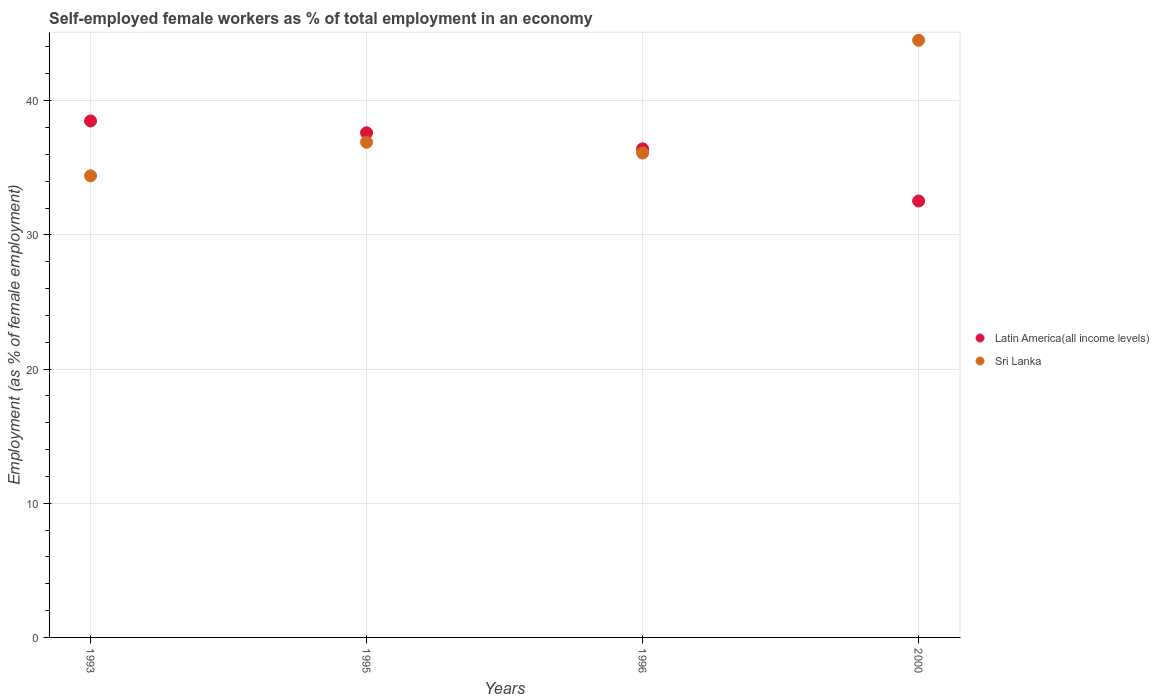How many different coloured dotlines are there?
Provide a short and direct response. 2. What is the percentage of self-employed female workers in Latin America(all income levels) in 1993?
Your response must be concise. 38.49. Across all years, what is the maximum percentage of self-employed female workers in Sri Lanka?
Ensure brevity in your answer.  44.5. Across all years, what is the minimum percentage of self-employed female workers in Sri Lanka?
Give a very brief answer. 34.4. In which year was the percentage of self-employed female workers in Latin America(all income levels) minimum?
Keep it short and to the point. 2000. What is the total percentage of self-employed female workers in Sri Lanka in the graph?
Ensure brevity in your answer.  151.9. What is the difference between the percentage of self-employed female workers in Sri Lanka in 1995 and that in 1996?
Provide a short and direct response. 0.8. What is the difference between the percentage of self-employed female workers in Sri Lanka in 1993 and the percentage of self-employed female workers in Latin America(all income levels) in 2000?
Provide a succinct answer. 1.88. What is the average percentage of self-employed female workers in Latin America(all income levels) per year?
Keep it short and to the point. 36.26. In the year 1995, what is the difference between the percentage of self-employed female workers in Sri Lanka and percentage of self-employed female workers in Latin America(all income levels)?
Your response must be concise. -0.71. What is the ratio of the percentage of self-employed female workers in Sri Lanka in 1993 to that in 2000?
Your response must be concise. 0.77. Is the percentage of self-employed female workers in Latin America(all income levels) in 1995 less than that in 1996?
Offer a very short reply. No. Is the difference between the percentage of self-employed female workers in Sri Lanka in 1993 and 1995 greater than the difference between the percentage of self-employed female workers in Latin America(all income levels) in 1993 and 1995?
Your answer should be compact. No. What is the difference between the highest and the second highest percentage of self-employed female workers in Latin America(all income levels)?
Your answer should be compact. 0.88. What is the difference between the highest and the lowest percentage of self-employed female workers in Latin America(all income levels)?
Your answer should be very brief. 5.97. Is the sum of the percentage of self-employed female workers in Latin America(all income levels) in 1995 and 1996 greater than the maximum percentage of self-employed female workers in Sri Lanka across all years?
Keep it short and to the point. Yes. Does the percentage of self-employed female workers in Sri Lanka monotonically increase over the years?
Your answer should be very brief. No. Is the percentage of self-employed female workers in Sri Lanka strictly greater than the percentage of self-employed female workers in Latin America(all income levels) over the years?
Offer a terse response. No. How many dotlines are there?
Ensure brevity in your answer.  2. Are the values on the major ticks of Y-axis written in scientific E-notation?
Your answer should be compact. No. Does the graph contain any zero values?
Your response must be concise. No. Does the graph contain grids?
Provide a short and direct response. Yes. How many legend labels are there?
Make the answer very short. 2. What is the title of the graph?
Provide a short and direct response. Self-employed female workers as % of total employment in an economy. Does "Micronesia" appear as one of the legend labels in the graph?
Your answer should be very brief. No. What is the label or title of the Y-axis?
Your answer should be compact. Employment (as % of female employment). What is the Employment (as % of female employment) in Latin America(all income levels) in 1993?
Your answer should be very brief. 38.49. What is the Employment (as % of female employment) in Sri Lanka in 1993?
Keep it short and to the point. 34.4. What is the Employment (as % of female employment) of Latin America(all income levels) in 1995?
Provide a succinct answer. 37.61. What is the Employment (as % of female employment) of Sri Lanka in 1995?
Offer a terse response. 36.9. What is the Employment (as % of female employment) in Latin America(all income levels) in 1996?
Provide a short and direct response. 36.41. What is the Employment (as % of female employment) in Sri Lanka in 1996?
Your response must be concise. 36.1. What is the Employment (as % of female employment) in Latin America(all income levels) in 2000?
Provide a short and direct response. 32.52. What is the Employment (as % of female employment) of Sri Lanka in 2000?
Your answer should be compact. 44.5. Across all years, what is the maximum Employment (as % of female employment) in Latin America(all income levels)?
Keep it short and to the point. 38.49. Across all years, what is the maximum Employment (as % of female employment) of Sri Lanka?
Provide a succinct answer. 44.5. Across all years, what is the minimum Employment (as % of female employment) of Latin America(all income levels)?
Keep it short and to the point. 32.52. Across all years, what is the minimum Employment (as % of female employment) of Sri Lanka?
Your answer should be very brief. 34.4. What is the total Employment (as % of female employment) of Latin America(all income levels) in the graph?
Your response must be concise. 145.03. What is the total Employment (as % of female employment) of Sri Lanka in the graph?
Provide a short and direct response. 151.9. What is the difference between the Employment (as % of female employment) of Latin America(all income levels) in 1993 and that in 1995?
Your answer should be compact. 0.88. What is the difference between the Employment (as % of female employment) of Sri Lanka in 1993 and that in 1995?
Your answer should be compact. -2.5. What is the difference between the Employment (as % of female employment) of Latin America(all income levels) in 1993 and that in 1996?
Ensure brevity in your answer.  2.08. What is the difference between the Employment (as % of female employment) of Sri Lanka in 1993 and that in 1996?
Keep it short and to the point. -1.7. What is the difference between the Employment (as % of female employment) in Latin America(all income levels) in 1993 and that in 2000?
Your answer should be compact. 5.97. What is the difference between the Employment (as % of female employment) in Sri Lanka in 1993 and that in 2000?
Your answer should be compact. -10.1. What is the difference between the Employment (as % of female employment) in Latin America(all income levels) in 1995 and that in 1996?
Provide a short and direct response. 1.2. What is the difference between the Employment (as % of female employment) in Sri Lanka in 1995 and that in 1996?
Provide a short and direct response. 0.8. What is the difference between the Employment (as % of female employment) in Latin America(all income levels) in 1995 and that in 2000?
Make the answer very short. 5.08. What is the difference between the Employment (as % of female employment) of Sri Lanka in 1995 and that in 2000?
Ensure brevity in your answer.  -7.6. What is the difference between the Employment (as % of female employment) in Latin America(all income levels) in 1996 and that in 2000?
Provide a short and direct response. 3.89. What is the difference between the Employment (as % of female employment) of Sri Lanka in 1996 and that in 2000?
Provide a short and direct response. -8.4. What is the difference between the Employment (as % of female employment) of Latin America(all income levels) in 1993 and the Employment (as % of female employment) of Sri Lanka in 1995?
Offer a very short reply. 1.59. What is the difference between the Employment (as % of female employment) of Latin America(all income levels) in 1993 and the Employment (as % of female employment) of Sri Lanka in 1996?
Offer a terse response. 2.39. What is the difference between the Employment (as % of female employment) in Latin America(all income levels) in 1993 and the Employment (as % of female employment) in Sri Lanka in 2000?
Make the answer very short. -6.01. What is the difference between the Employment (as % of female employment) in Latin America(all income levels) in 1995 and the Employment (as % of female employment) in Sri Lanka in 1996?
Keep it short and to the point. 1.51. What is the difference between the Employment (as % of female employment) in Latin America(all income levels) in 1995 and the Employment (as % of female employment) in Sri Lanka in 2000?
Make the answer very short. -6.89. What is the difference between the Employment (as % of female employment) in Latin America(all income levels) in 1996 and the Employment (as % of female employment) in Sri Lanka in 2000?
Your answer should be compact. -8.09. What is the average Employment (as % of female employment) of Latin America(all income levels) per year?
Keep it short and to the point. 36.26. What is the average Employment (as % of female employment) of Sri Lanka per year?
Ensure brevity in your answer.  37.98. In the year 1993, what is the difference between the Employment (as % of female employment) in Latin America(all income levels) and Employment (as % of female employment) in Sri Lanka?
Keep it short and to the point. 4.09. In the year 1995, what is the difference between the Employment (as % of female employment) in Latin America(all income levels) and Employment (as % of female employment) in Sri Lanka?
Offer a terse response. 0.71. In the year 1996, what is the difference between the Employment (as % of female employment) in Latin America(all income levels) and Employment (as % of female employment) in Sri Lanka?
Your answer should be compact. 0.31. In the year 2000, what is the difference between the Employment (as % of female employment) in Latin America(all income levels) and Employment (as % of female employment) in Sri Lanka?
Your answer should be compact. -11.98. What is the ratio of the Employment (as % of female employment) of Latin America(all income levels) in 1993 to that in 1995?
Give a very brief answer. 1.02. What is the ratio of the Employment (as % of female employment) in Sri Lanka in 1993 to that in 1995?
Give a very brief answer. 0.93. What is the ratio of the Employment (as % of female employment) in Latin America(all income levels) in 1993 to that in 1996?
Your answer should be compact. 1.06. What is the ratio of the Employment (as % of female employment) of Sri Lanka in 1993 to that in 1996?
Provide a short and direct response. 0.95. What is the ratio of the Employment (as % of female employment) in Latin America(all income levels) in 1993 to that in 2000?
Ensure brevity in your answer.  1.18. What is the ratio of the Employment (as % of female employment) of Sri Lanka in 1993 to that in 2000?
Your answer should be very brief. 0.77. What is the ratio of the Employment (as % of female employment) in Latin America(all income levels) in 1995 to that in 1996?
Keep it short and to the point. 1.03. What is the ratio of the Employment (as % of female employment) in Sri Lanka in 1995 to that in 1996?
Your answer should be very brief. 1.02. What is the ratio of the Employment (as % of female employment) of Latin America(all income levels) in 1995 to that in 2000?
Provide a short and direct response. 1.16. What is the ratio of the Employment (as % of female employment) of Sri Lanka in 1995 to that in 2000?
Your answer should be compact. 0.83. What is the ratio of the Employment (as % of female employment) of Latin America(all income levels) in 1996 to that in 2000?
Keep it short and to the point. 1.12. What is the ratio of the Employment (as % of female employment) in Sri Lanka in 1996 to that in 2000?
Your response must be concise. 0.81. What is the difference between the highest and the second highest Employment (as % of female employment) in Latin America(all income levels)?
Your answer should be very brief. 0.88. What is the difference between the highest and the second highest Employment (as % of female employment) in Sri Lanka?
Offer a very short reply. 7.6. What is the difference between the highest and the lowest Employment (as % of female employment) of Latin America(all income levels)?
Your answer should be compact. 5.97. 